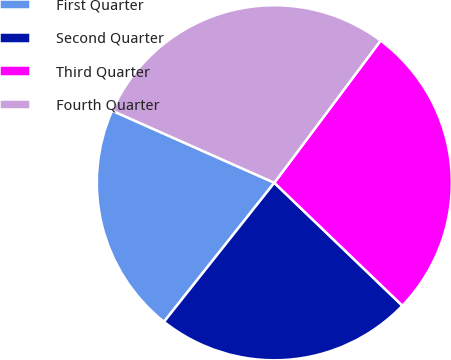<chart> <loc_0><loc_0><loc_500><loc_500><pie_chart><fcel>First Quarter<fcel>Second Quarter<fcel>Third Quarter<fcel>Fourth Quarter<nl><fcel>20.98%<fcel>23.5%<fcel>26.96%<fcel>28.56%<nl></chart> 